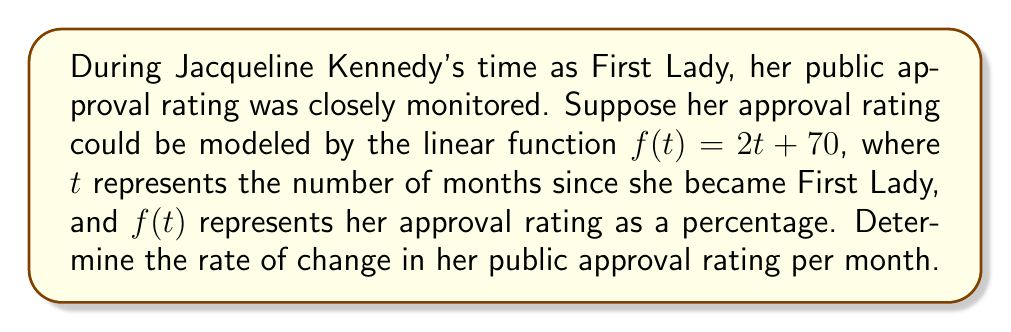Can you answer this question? To determine the rate of change in Jacqueline Kennedy's public approval rating, we need to analyze the given linear function:

$f(t) = 2t + 70$

In a linear function of the form $f(t) = mt + b$:
- $m$ represents the slope of the line
- $b$ represents the y-intercept

The slope $m$ is the rate of change of the function. It tells us how much the dependent variable (approval rating) changes for each unit increase in the independent variable (time in months).

In this case:
$m = 2$

This means that for each month that passes ($t$ increases by 1), the approval rating $f(t)$ increases by 2 percentage points.

Therefore, the rate of change in Jacqueline Kennedy's public approval rating is 2 percentage points per month.
Answer: 2 percentage points per month 